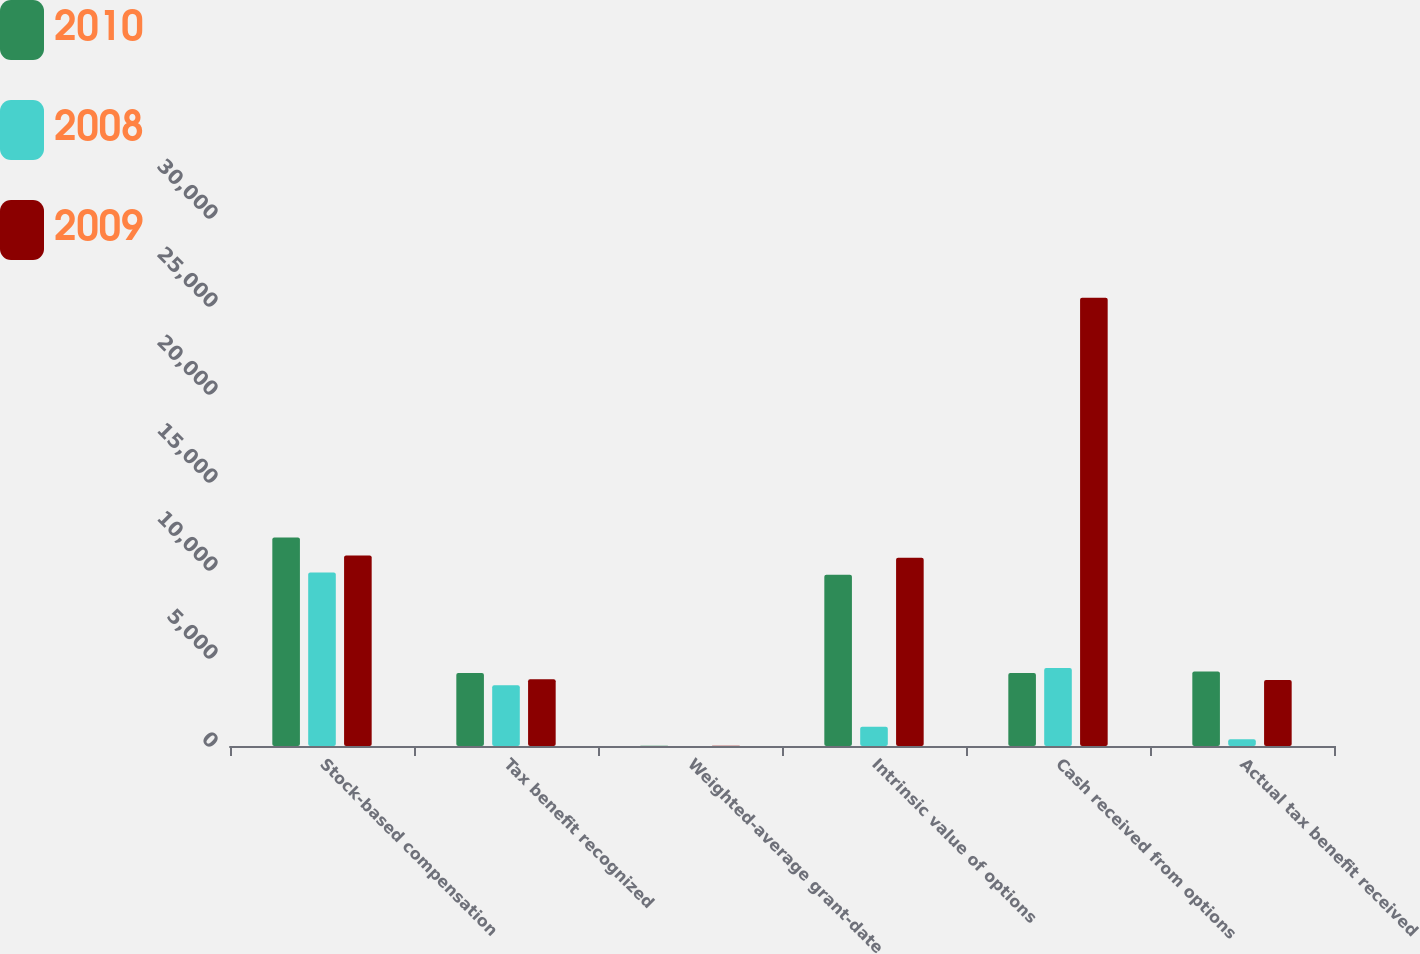<chart> <loc_0><loc_0><loc_500><loc_500><stacked_bar_chart><ecel><fcel>Stock-based compensation<fcel>Tax benefit recognized<fcel>Weighted-average grant-date<fcel>Intrinsic value of options<fcel>Cash received from options<fcel>Actual tax benefit received<nl><fcel>2010<fcel>11848<fcel>4147<fcel>15.53<fcel>9731<fcel>4147<fcel>4236<nl><fcel>2008<fcel>9860<fcel>3451<fcel>5.5<fcel>1088<fcel>4430<fcel>381<nl><fcel>2009<fcel>10823<fcel>3788<fcel>8.87<fcel>10700<fcel>25473<fcel>3745<nl></chart> 